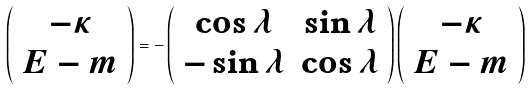<formula> <loc_0><loc_0><loc_500><loc_500>\left ( \begin{array} { c } - \kappa \\ E - m \end{array} \right ) = - \left ( \begin{array} { c c } \cos \lambda & \sin \lambda \\ - \sin \lambda & \cos \lambda \end{array} \right ) \left ( \begin{array} { c } - \kappa \\ E - m \end{array} \right )</formula> 